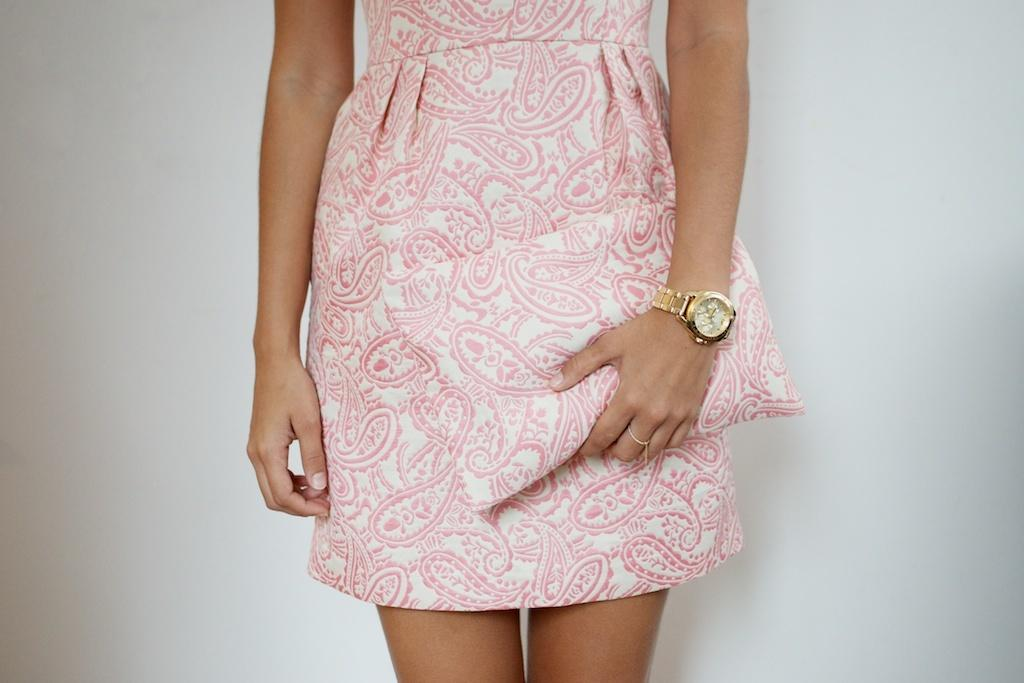What is the main subject in the image? There is a person standing in the image. What can be seen behind the person? There is a wall behind the person. Reasoning: Let's think step by step by step in order to produce the conversation. We start by identifying the main subject in the image, which is the person standing. Then, we expand the conversation to include the background, which is a wall. Each question is designed to elicit a specific detail about the image that is known from the provided facts. Absurd Question/Answer: What type of lamp is hanging from the ceiling in the image? There is no lamp visible in the image; it only features a person standing in front of a wall. What type of breath can be seen coming from the person in the image? There is no visible breath in the image, as it does not depict a cold or wintery scene. 